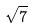<formula> <loc_0><loc_0><loc_500><loc_500>\sqrt { 7 }</formula> 